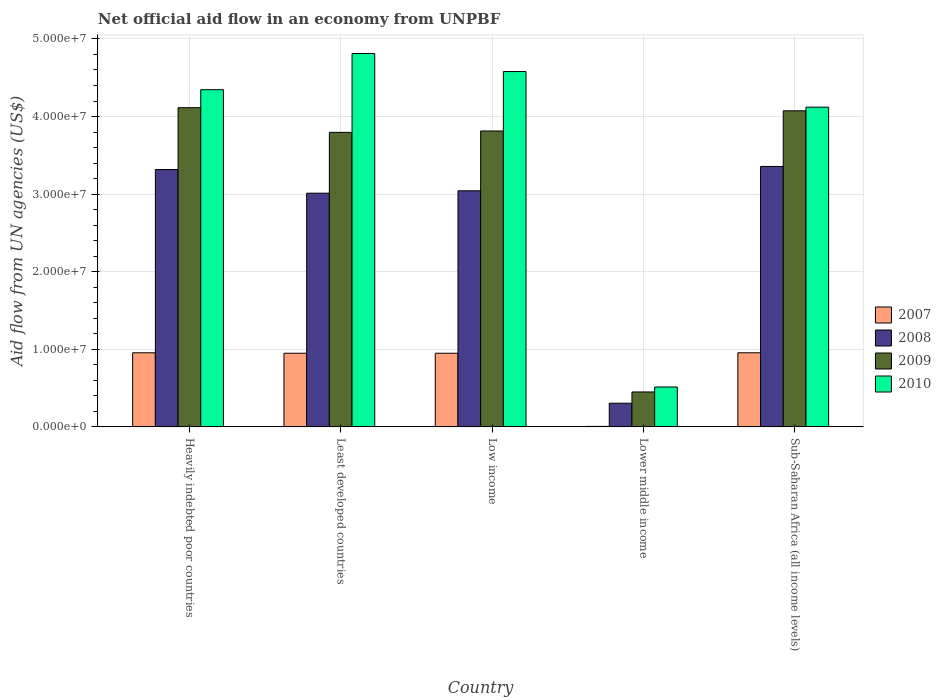How many groups of bars are there?
Ensure brevity in your answer.  5. Are the number of bars per tick equal to the number of legend labels?
Your answer should be very brief. Yes. Are the number of bars on each tick of the X-axis equal?
Keep it short and to the point. Yes. What is the label of the 2nd group of bars from the left?
Make the answer very short. Least developed countries. What is the net official aid flow in 2008 in Low income?
Provide a succinct answer. 3.04e+07. Across all countries, what is the maximum net official aid flow in 2008?
Keep it short and to the point. 3.36e+07. Across all countries, what is the minimum net official aid flow in 2009?
Offer a very short reply. 4.50e+06. In which country was the net official aid flow in 2010 maximum?
Your answer should be compact. Least developed countries. In which country was the net official aid flow in 2007 minimum?
Provide a succinct answer. Lower middle income. What is the total net official aid flow in 2007 in the graph?
Offer a very short reply. 3.81e+07. What is the difference between the net official aid flow in 2007 in Least developed countries and that in Lower middle income?
Give a very brief answer. 9.43e+06. What is the difference between the net official aid flow in 2008 in Lower middle income and the net official aid flow in 2010 in Heavily indebted poor countries?
Give a very brief answer. -4.04e+07. What is the average net official aid flow in 2007 per country?
Provide a short and direct response. 7.63e+06. What is the difference between the net official aid flow of/in 2008 and net official aid flow of/in 2007 in Lower middle income?
Your answer should be very brief. 2.99e+06. What is the ratio of the net official aid flow in 2007 in Least developed countries to that in Lower middle income?
Your answer should be very brief. 158.17. Is the net official aid flow in 2010 in Least developed countries less than that in Low income?
Offer a terse response. No. Is the difference between the net official aid flow in 2008 in Lower middle income and Sub-Saharan Africa (all income levels) greater than the difference between the net official aid flow in 2007 in Lower middle income and Sub-Saharan Africa (all income levels)?
Give a very brief answer. No. What is the difference between the highest and the lowest net official aid flow in 2008?
Make the answer very short. 3.05e+07. In how many countries, is the net official aid flow in 2008 greater than the average net official aid flow in 2008 taken over all countries?
Ensure brevity in your answer.  4. Is the sum of the net official aid flow in 2009 in Least developed countries and Low income greater than the maximum net official aid flow in 2007 across all countries?
Your response must be concise. Yes. Is it the case that in every country, the sum of the net official aid flow in 2008 and net official aid flow in 2009 is greater than the sum of net official aid flow in 2007 and net official aid flow in 2010?
Keep it short and to the point. No. How many bars are there?
Ensure brevity in your answer.  20. Are all the bars in the graph horizontal?
Your response must be concise. No. How many countries are there in the graph?
Ensure brevity in your answer.  5. Where does the legend appear in the graph?
Keep it short and to the point. Center right. How many legend labels are there?
Provide a succinct answer. 4. How are the legend labels stacked?
Provide a short and direct response. Vertical. What is the title of the graph?
Your answer should be compact. Net official aid flow in an economy from UNPBF. What is the label or title of the X-axis?
Offer a very short reply. Country. What is the label or title of the Y-axis?
Make the answer very short. Aid flow from UN agencies (US$). What is the Aid flow from UN agencies (US$) in 2007 in Heavily indebted poor countries?
Ensure brevity in your answer.  9.55e+06. What is the Aid flow from UN agencies (US$) of 2008 in Heavily indebted poor countries?
Offer a very short reply. 3.32e+07. What is the Aid flow from UN agencies (US$) in 2009 in Heavily indebted poor countries?
Offer a very short reply. 4.11e+07. What is the Aid flow from UN agencies (US$) in 2010 in Heavily indebted poor countries?
Your answer should be very brief. 4.35e+07. What is the Aid flow from UN agencies (US$) in 2007 in Least developed countries?
Keep it short and to the point. 9.49e+06. What is the Aid flow from UN agencies (US$) in 2008 in Least developed countries?
Your response must be concise. 3.01e+07. What is the Aid flow from UN agencies (US$) of 2009 in Least developed countries?
Provide a short and direct response. 3.80e+07. What is the Aid flow from UN agencies (US$) of 2010 in Least developed countries?
Keep it short and to the point. 4.81e+07. What is the Aid flow from UN agencies (US$) in 2007 in Low income?
Provide a short and direct response. 9.49e+06. What is the Aid flow from UN agencies (US$) of 2008 in Low income?
Offer a very short reply. 3.04e+07. What is the Aid flow from UN agencies (US$) in 2009 in Low income?
Offer a terse response. 3.81e+07. What is the Aid flow from UN agencies (US$) in 2010 in Low income?
Ensure brevity in your answer.  4.58e+07. What is the Aid flow from UN agencies (US$) in 2007 in Lower middle income?
Offer a very short reply. 6.00e+04. What is the Aid flow from UN agencies (US$) of 2008 in Lower middle income?
Your answer should be compact. 3.05e+06. What is the Aid flow from UN agencies (US$) in 2009 in Lower middle income?
Your response must be concise. 4.50e+06. What is the Aid flow from UN agencies (US$) of 2010 in Lower middle income?
Provide a short and direct response. 5.14e+06. What is the Aid flow from UN agencies (US$) of 2007 in Sub-Saharan Africa (all income levels)?
Offer a terse response. 9.55e+06. What is the Aid flow from UN agencies (US$) of 2008 in Sub-Saharan Africa (all income levels)?
Provide a succinct answer. 3.36e+07. What is the Aid flow from UN agencies (US$) of 2009 in Sub-Saharan Africa (all income levels)?
Make the answer very short. 4.07e+07. What is the Aid flow from UN agencies (US$) of 2010 in Sub-Saharan Africa (all income levels)?
Your answer should be compact. 4.12e+07. Across all countries, what is the maximum Aid flow from UN agencies (US$) of 2007?
Your answer should be very brief. 9.55e+06. Across all countries, what is the maximum Aid flow from UN agencies (US$) in 2008?
Offer a terse response. 3.36e+07. Across all countries, what is the maximum Aid flow from UN agencies (US$) in 2009?
Make the answer very short. 4.11e+07. Across all countries, what is the maximum Aid flow from UN agencies (US$) in 2010?
Offer a terse response. 4.81e+07. Across all countries, what is the minimum Aid flow from UN agencies (US$) of 2008?
Your answer should be very brief. 3.05e+06. Across all countries, what is the minimum Aid flow from UN agencies (US$) in 2009?
Provide a short and direct response. 4.50e+06. Across all countries, what is the minimum Aid flow from UN agencies (US$) of 2010?
Provide a succinct answer. 5.14e+06. What is the total Aid flow from UN agencies (US$) of 2007 in the graph?
Your answer should be compact. 3.81e+07. What is the total Aid flow from UN agencies (US$) of 2008 in the graph?
Provide a short and direct response. 1.30e+08. What is the total Aid flow from UN agencies (US$) of 2009 in the graph?
Your answer should be very brief. 1.62e+08. What is the total Aid flow from UN agencies (US$) of 2010 in the graph?
Ensure brevity in your answer.  1.84e+08. What is the difference between the Aid flow from UN agencies (US$) in 2007 in Heavily indebted poor countries and that in Least developed countries?
Offer a very short reply. 6.00e+04. What is the difference between the Aid flow from UN agencies (US$) in 2008 in Heavily indebted poor countries and that in Least developed countries?
Ensure brevity in your answer.  3.05e+06. What is the difference between the Aid flow from UN agencies (US$) in 2009 in Heavily indebted poor countries and that in Least developed countries?
Provide a short and direct response. 3.18e+06. What is the difference between the Aid flow from UN agencies (US$) of 2010 in Heavily indebted poor countries and that in Least developed countries?
Offer a terse response. -4.66e+06. What is the difference between the Aid flow from UN agencies (US$) of 2007 in Heavily indebted poor countries and that in Low income?
Keep it short and to the point. 6.00e+04. What is the difference between the Aid flow from UN agencies (US$) in 2008 in Heavily indebted poor countries and that in Low income?
Your answer should be compact. 2.74e+06. What is the difference between the Aid flow from UN agencies (US$) of 2010 in Heavily indebted poor countries and that in Low income?
Make the answer very short. -2.34e+06. What is the difference between the Aid flow from UN agencies (US$) of 2007 in Heavily indebted poor countries and that in Lower middle income?
Provide a short and direct response. 9.49e+06. What is the difference between the Aid flow from UN agencies (US$) in 2008 in Heavily indebted poor countries and that in Lower middle income?
Provide a succinct answer. 3.01e+07. What is the difference between the Aid flow from UN agencies (US$) in 2009 in Heavily indebted poor countries and that in Lower middle income?
Ensure brevity in your answer.  3.66e+07. What is the difference between the Aid flow from UN agencies (US$) in 2010 in Heavily indebted poor countries and that in Lower middle income?
Offer a very short reply. 3.83e+07. What is the difference between the Aid flow from UN agencies (US$) in 2007 in Heavily indebted poor countries and that in Sub-Saharan Africa (all income levels)?
Offer a very short reply. 0. What is the difference between the Aid flow from UN agencies (US$) in 2008 in Heavily indebted poor countries and that in Sub-Saharan Africa (all income levels)?
Ensure brevity in your answer.  -4.00e+05. What is the difference between the Aid flow from UN agencies (US$) of 2009 in Heavily indebted poor countries and that in Sub-Saharan Africa (all income levels)?
Provide a succinct answer. 4.00e+05. What is the difference between the Aid flow from UN agencies (US$) of 2010 in Heavily indebted poor countries and that in Sub-Saharan Africa (all income levels)?
Provide a short and direct response. 2.25e+06. What is the difference between the Aid flow from UN agencies (US$) of 2008 in Least developed countries and that in Low income?
Give a very brief answer. -3.10e+05. What is the difference between the Aid flow from UN agencies (US$) in 2010 in Least developed countries and that in Low income?
Provide a succinct answer. 2.32e+06. What is the difference between the Aid flow from UN agencies (US$) in 2007 in Least developed countries and that in Lower middle income?
Your answer should be compact. 9.43e+06. What is the difference between the Aid flow from UN agencies (US$) in 2008 in Least developed countries and that in Lower middle income?
Provide a succinct answer. 2.71e+07. What is the difference between the Aid flow from UN agencies (US$) in 2009 in Least developed countries and that in Lower middle income?
Ensure brevity in your answer.  3.35e+07. What is the difference between the Aid flow from UN agencies (US$) of 2010 in Least developed countries and that in Lower middle income?
Your response must be concise. 4.30e+07. What is the difference between the Aid flow from UN agencies (US$) in 2008 in Least developed countries and that in Sub-Saharan Africa (all income levels)?
Ensure brevity in your answer.  -3.45e+06. What is the difference between the Aid flow from UN agencies (US$) of 2009 in Least developed countries and that in Sub-Saharan Africa (all income levels)?
Your answer should be very brief. -2.78e+06. What is the difference between the Aid flow from UN agencies (US$) in 2010 in Least developed countries and that in Sub-Saharan Africa (all income levels)?
Provide a succinct answer. 6.91e+06. What is the difference between the Aid flow from UN agencies (US$) in 2007 in Low income and that in Lower middle income?
Make the answer very short. 9.43e+06. What is the difference between the Aid flow from UN agencies (US$) in 2008 in Low income and that in Lower middle income?
Keep it short and to the point. 2.74e+07. What is the difference between the Aid flow from UN agencies (US$) in 2009 in Low income and that in Lower middle income?
Keep it short and to the point. 3.36e+07. What is the difference between the Aid flow from UN agencies (US$) of 2010 in Low income and that in Lower middle income?
Provide a succinct answer. 4.07e+07. What is the difference between the Aid flow from UN agencies (US$) in 2008 in Low income and that in Sub-Saharan Africa (all income levels)?
Make the answer very short. -3.14e+06. What is the difference between the Aid flow from UN agencies (US$) of 2009 in Low income and that in Sub-Saharan Africa (all income levels)?
Make the answer very short. -2.60e+06. What is the difference between the Aid flow from UN agencies (US$) in 2010 in Low income and that in Sub-Saharan Africa (all income levels)?
Make the answer very short. 4.59e+06. What is the difference between the Aid flow from UN agencies (US$) in 2007 in Lower middle income and that in Sub-Saharan Africa (all income levels)?
Keep it short and to the point. -9.49e+06. What is the difference between the Aid flow from UN agencies (US$) in 2008 in Lower middle income and that in Sub-Saharan Africa (all income levels)?
Your response must be concise. -3.05e+07. What is the difference between the Aid flow from UN agencies (US$) in 2009 in Lower middle income and that in Sub-Saharan Africa (all income levels)?
Give a very brief answer. -3.62e+07. What is the difference between the Aid flow from UN agencies (US$) of 2010 in Lower middle income and that in Sub-Saharan Africa (all income levels)?
Give a very brief answer. -3.61e+07. What is the difference between the Aid flow from UN agencies (US$) of 2007 in Heavily indebted poor countries and the Aid flow from UN agencies (US$) of 2008 in Least developed countries?
Give a very brief answer. -2.06e+07. What is the difference between the Aid flow from UN agencies (US$) of 2007 in Heavily indebted poor countries and the Aid flow from UN agencies (US$) of 2009 in Least developed countries?
Ensure brevity in your answer.  -2.84e+07. What is the difference between the Aid flow from UN agencies (US$) of 2007 in Heavily indebted poor countries and the Aid flow from UN agencies (US$) of 2010 in Least developed countries?
Make the answer very short. -3.86e+07. What is the difference between the Aid flow from UN agencies (US$) of 2008 in Heavily indebted poor countries and the Aid flow from UN agencies (US$) of 2009 in Least developed countries?
Your response must be concise. -4.79e+06. What is the difference between the Aid flow from UN agencies (US$) in 2008 in Heavily indebted poor countries and the Aid flow from UN agencies (US$) in 2010 in Least developed countries?
Your answer should be compact. -1.50e+07. What is the difference between the Aid flow from UN agencies (US$) in 2009 in Heavily indebted poor countries and the Aid flow from UN agencies (US$) in 2010 in Least developed countries?
Offer a terse response. -6.98e+06. What is the difference between the Aid flow from UN agencies (US$) of 2007 in Heavily indebted poor countries and the Aid flow from UN agencies (US$) of 2008 in Low income?
Offer a very short reply. -2.09e+07. What is the difference between the Aid flow from UN agencies (US$) of 2007 in Heavily indebted poor countries and the Aid flow from UN agencies (US$) of 2009 in Low income?
Offer a very short reply. -2.86e+07. What is the difference between the Aid flow from UN agencies (US$) of 2007 in Heavily indebted poor countries and the Aid flow from UN agencies (US$) of 2010 in Low income?
Provide a short and direct response. -3.62e+07. What is the difference between the Aid flow from UN agencies (US$) in 2008 in Heavily indebted poor countries and the Aid flow from UN agencies (US$) in 2009 in Low income?
Your answer should be compact. -4.97e+06. What is the difference between the Aid flow from UN agencies (US$) of 2008 in Heavily indebted poor countries and the Aid flow from UN agencies (US$) of 2010 in Low income?
Offer a terse response. -1.26e+07. What is the difference between the Aid flow from UN agencies (US$) of 2009 in Heavily indebted poor countries and the Aid flow from UN agencies (US$) of 2010 in Low income?
Provide a short and direct response. -4.66e+06. What is the difference between the Aid flow from UN agencies (US$) in 2007 in Heavily indebted poor countries and the Aid flow from UN agencies (US$) in 2008 in Lower middle income?
Offer a terse response. 6.50e+06. What is the difference between the Aid flow from UN agencies (US$) in 2007 in Heavily indebted poor countries and the Aid flow from UN agencies (US$) in 2009 in Lower middle income?
Offer a terse response. 5.05e+06. What is the difference between the Aid flow from UN agencies (US$) of 2007 in Heavily indebted poor countries and the Aid flow from UN agencies (US$) of 2010 in Lower middle income?
Make the answer very short. 4.41e+06. What is the difference between the Aid flow from UN agencies (US$) in 2008 in Heavily indebted poor countries and the Aid flow from UN agencies (US$) in 2009 in Lower middle income?
Provide a succinct answer. 2.87e+07. What is the difference between the Aid flow from UN agencies (US$) in 2008 in Heavily indebted poor countries and the Aid flow from UN agencies (US$) in 2010 in Lower middle income?
Ensure brevity in your answer.  2.80e+07. What is the difference between the Aid flow from UN agencies (US$) in 2009 in Heavily indebted poor countries and the Aid flow from UN agencies (US$) in 2010 in Lower middle income?
Give a very brief answer. 3.60e+07. What is the difference between the Aid flow from UN agencies (US$) of 2007 in Heavily indebted poor countries and the Aid flow from UN agencies (US$) of 2008 in Sub-Saharan Africa (all income levels)?
Give a very brief answer. -2.40e+07. What is the difference between the Aid flow from UN agencies (US$) in 2007 in Heavily indebted poor countries and the Aid flow from UN agencies (US$) in 2009 in Sub-Saharan Africa (all income levels)?
Your response must be concise. -3.12e+07. What is the difference between the Aid flow from UN agencies (US$) of 2007 in Heavily indebted poor countries and the Aid flow from UN agencies (US$) of 2010 in Sub-Saharan Africa (all income levels)?
Your answer should be compact. -3.17e+07. What is the difference between the Aid flow from UN agencies (US$) of 2008 in Heavily indebted poor countries and the Aid flow from UN agencies (US$) of 2009 in Sub-Saharan Africa (all income levels)?
Provide a succinct answer. -7.57e+06. What is the difference between the Aid flow from UN agencies (US$) of 2008 in Heavily indebted poor countries and the Aid flow from UN agencies (US$) of 2010 in Sub-Saharan Africa (all income levels)?
Your answer should be very brief. -8.04e+06. What is the difference between the Aid flow from UN agencies (US$) of 2007 in Least developed countries and the Aid flow from UN agencies (US$) of 2008 in Low income?
Provide a short and direct response. -2.09e+07. What is the difference between the Aid flow from UN agencies (US$) in 2007 in Least developed countries and the Aid flow from UN agencies (US$) in 2009 in Low income?
Offer a terse response. -2.86e+07. What is the difference between the Aid flow from UN agencies (US$) in 2007 in Least developed countries and the Aid flow from UN agencies (US$) in 2010 in Low income?
Provide a succinct answer. -3.63e+07. What is the difference between the Aid flow from UN agencies (US$) in 2008 in Least developed countries and the Aid flow from UN agencies (US$) in 2009 in Low income?
Keep it short and to the point. -8.02e+06. What is the difference between the Aid flow from UN agencies (US$) of 2008 in Least developed countries and the Aid flow from UN agencies (US$) of 2010 in Low income?
Offer a very short reply. -1.57e+07. What is the difference between the Aid flow from UN agencies (US$) of 2009 in Least developed countries and the Aid flow from UN agencies (US$) of 2010 in Low income?
Make the answer very short. -7.84e+06. What is the difference between the Aid flow from UN agencies (US$) in 2007 in Least developed countries and the Aid flow from UN agencies (US$) in 2008 in Lower middle income?
Your answer should be compact. 6.44e+06. What is the difference between the Aid flow from UN agencies (US$) in 2007 in Least developed countries and the Aid flow from UN agencies (US$) in 2009 in Lower middle income?
Give a very brief answer. 4.99e+06. What is the difference between the Aid flow from UN agencies (US$) in 2007 in Least developed countries and the Aid flow from UN agencies (US$) in 2010 in Lower middle income?
Offer a terse response. 4.35e+06. What is the difference between the Aid flow from UN agencies (US$) in 2008 in Least developed countries and the Aid flow from UN agencies (US$) in 2009 in Lower middle income?
Your answer should be compact. 2.56e+07. What is the difference between the Aid flow from UN agencies (US$) in 2008 in Least developed countries and the Aid flow from UN agencies (US$) in 2010 in Lower middle income?
Offer a terse response. 2.50e+07. What is the difference between the Aid flow from UN agencies (US$) in 2009 in Least developed countries and the Aid flow from UN agencies (US$) in 2010 in Lower middle income?
Ensure brevity in your answer.  3.28e+07. What is the difference between the Aid flow from UN agencies (US$) in 2007 in Least developed countries and the Aid flow from UN agencies (US$) in 2008 in Sub-Saharan Africa (all income levels)?
Provide a succinct answer. -2.41e+07. What is the difference between the Aid flow from UN agencies (US$) in 2007 in Least developed countries and the Aid flow from UN agencies (US$) in 2009 in Sub-Saharan Africa (all income levels)?
Keep it short and to the point. -3.12e+07. What is the difference between the Aid flow from UN agencies (US$) in 2007 in Least developed countries and the Aid flow from UN agencies (US$) in 2010 in Sub-Saharan Africa (all income levels)?
Give a very brief answer. -3.17e+07. What is the difference between the Aid flow from UN agencies (US$) in 2008 in Least developed countries and the Aid flow from UN agencies (US$) in 2009 in Sub-Saharan Africa (all income levels)?
Keep it short and to the point. -1.06e+07. What is the difference between the Aid flow from UN agencies (US$) in 2008 in Least developed countries and the Aid flow from UN agencies (US$) in 2010 in Sub-Saharan Africa (all income levels)?
Provide a succinct answer. -1.11e+07. What is the difference between the Aid flow from UN agencies (US$) of 2009 in Least developed countries and the Aid flow from UN agencies (US$) of 2010 in Sub-Saharan Africa (all income levels)?
Keep it short and to the point. -3.25e+06. What is the difference between the Aid flow from UN agencies (US$) in 2007 in Low income and the Aid flow from UN agencies (US$) in 2008 in Lower middle income?
Give a very brief answer. 6.44e+06. What is the difference between the Aid flow from UN agencies (US$) of 2007 in Low income and the Aid flow from UN agencies (US$) of 2009 in Lower middle income?
Your answer should be very brief. 4.99e+06. What is the difference between the Aid flow from UN agencies (US$) of 2007 in Low income and the Aid flow from UN agencies (US$) of 2010 in Lower middle income?
Offer a terse response. 4.35e+06. What is the difference between the Aid flow from UN agencies (US$) in 2008 in Low income and the Aid flow from UN agencies (US$) in 2009 in Lower middle income?
Give a very brief answer. 2.59e+07. What is the difference between the Aid flow from UN agencies (US$) in 2008 in Low income and the Aid flow from UN agencies (US$) in 2010 in Lower middle income?
Keep it short and to the point. 2.53e+07. What is the difference between the Aid flow from UN agencies (US$) of 2009 in Low income and the Aid flow from UN agencies (US$) of 2010 in Lower middle income?
Make the answer very short. 3.30e+07. What is the difference between the Aid flow from UN agencies (US$) in 2007 in Low income and the Aid flow from UN agencies (US$) in 2008 in Sub-Saharan Africa (all income levels)?
Your answer should be very brief. -2.41e+07. What is the difference between the Aid flow from UN agencies (US$) of 2007 in Low income and the Aid flow from UN agencies (US$) of 2009 in Sub-Saharan Africa (all income levels)?
Your response must be concise. -3.12e+07. What is the difference between the Aid flow from UN agencies (US$) in 2007 in Low income and the Aid flow from UN agencies (US$) in 2010 in Sub-Saharan Africa (all income levels)?
Your answer should be compact. -3.17e+07. What is the difference between the Aid flow from UN agencies (US$) of 2008 in Low income and the Aid flow from UN agencies (US$) of 2009 in Sub-Saharan Africa (all income levels)?
Your response must be concise. -1.03e+07. What is the difference between the Aid flow from UN agencies (US$) of 2008 in Low income and the Aid flow from UN agencies (US$) of 2010 in Sub-Saharan Africa (all income levels)?
Offer a very short reply. -1.08e+07. What is the difference between the Aid flow from UN agencies (US$) of 2009 in Low income and the Aid flow from UN agencies (US$) of 2010 in Sub-Saharan Africa (all income levels)?
Your response must be concise. -3.07e+06. What is the difference between the Aid flow from UN agencies (US$) of 2007 in Lower middle income and the Aid flow from UN agencies (US$) of 2008 in Sub-Saharan Africa (all income levels)?
Provide a short and direct response. -3.35e+07. What is the difference between the Aid flow from UN agencies (US$) of 2007 in Lower middle income and the Aid flow from UN agencies (US$) of 2009 in Sub-Saharan Africa (all income levels)?
Your answer should be compact. -4.07e+07. What is the difference between the Aid flow from UN agencies (US$) of 2007 in Lower middle income and the Aid flow from UN agencies (US$) of 2010 in Sub-Saharan Africa (all income levels)?
Your answer should be very brief. -4.12e+07. What is the difference between the Aid flow from UN agencies (US$) of 2008 in Lower middle income and the Aid flow from UN agencies (US$) of 2009 in Sub-Saharan Africa (all income levels)?
Keep it short and to the point. -3.77e+07. What is the difference between the Aid flow from UN agencies (US$) of 2008 in Lower middle income and the Aid flow from UN agencies (US$) of 2010 in Sub-Saharan Africa (all income levels)?
Offer a very short reply. -3.82e+07. What is the difference between the Aid flow from UN agencies (US$) in 2009 in Lower middle income and the Aid flow from UN agencies (US$) in 2010 in Sub-Saharan Africa (all income levels)?
Ensure brevity in your answer.  -3.67e+07. What is the average Aid flow from UN agencies (US$) of 2007 per country?
Give a very brief answer. 7.63e+06. What is the average Aid flow from UN agencies (US$) of 2008 per country?
Provide a short and direct response. 2.61e+07. What is the average Aid flow from UN agencies (US$) in 2009 per country?
Your response must be concise. 3.25e+07. What is the average Aid flow from UN agencies (US$) of 2010 per country?
Offer a terse response. 3.67e+07. What is the difference between the Aid flow from UN agencies (US$) in 2007 and Aid flow from UN agencies (US$) in 2008 in Heavily indebted poor countries?
Keep it short and to the point. -2.36e+07. What is the difference between the Aid flow from UN agencies (US$) of 2007 and Aid flow from UN agencies (US$) of 2009 in Heavily indebted poor countries?
Keep it short and to the point. -3.16e+07. What is the difference between the Aid flow from UN agencies (US$) in 2007 and Aid flow from UN agencies (US$) in 2010 in Heavily indebted poor countries?
Ensure brevity in your answer.  -3.39e+07. What is the difference between the Aid flow from UN agencies (US$) in 2008 and Aid flow from UN agencies (US$) in 2009 in Heavily indebted poor countries?
Make the answer very short. -7.97e+06. What is the difference between the Aid flow from UN agencies (US$) in 2008 and Aid flow from UN agencies (US$) in 2010 in Heavily indebted poor countries?
Your answer should be compact. -1.03e+07. What is the difference between the Aid flow from UN agencies (US$) in 2009 and Aid flow from UN agencies (US$) in 2010 in Heavily indebted poor countries?
Offer a very short reply. -2.32e+06. What is the difference between the Aid flow from UN agencies (US$) in 2007 and Aid flow from UN agencies (US$) in 2008 in Least developed countries?
Provide a succinct answer. -2.06e+07. What is the difference between the Aid flow from UN agencies (US$) in 2007 and Aid flow from UN agencies (US$) in 2009 in Least developed countries?
Your response must be concise. -2.85e+07. What is the difference between the Aid flow from UN agencies (US$) in 2007 and Aid flow from UN agencies (US$) in 2010 in Least developed countries?
Keep it short and to the point. -3.86e+07. What is the difference between the Aid flow from UN agencies (US$) in 2008 and Aid flow from UN agencies (US$) in 2009 in Least developed countries?
Provide a succinct answer. -7.84e+06. What is the difference between the Aid flow from UN agencies (US$) of 2008 and Aid flow from UN agencies (US$) of 2010 in Least developed countries?
Provide a succinct answer. -1.80e+07. What is the difference between the Aid flow from UN agencies (US$) in 2009 and Aid flow from UN agencies (US$) in 2010 in Least developed countries?
Offer a terse response. -1.02e+07. What is the difference between the Aid flow from UN agencies (US$) in 2007 and Aid flow from UN agencies (US$) in 2008 in Low income?
Give a very brief answer. -2.09e+07. What is the difference between the Aid flow from UN agencies (US$) of 2007 and Aid flow from UN agencies (US$) of 2009 in Low income?
Keep it short and to the point. -2.86e+07. What is the difference between the Aid flow from UN agencies (US$) in 2007 and Aid flow from UN agencies (US$) in 2010 in Low income?
Offer a terse response. -3.63e+07. What is the difference between the Aid flow from UN agencies (US$) of 2008 and Aid flow from UN agencies (US$) of 2009 in Low income?
Provide a short and direct response. -7.71e+06. What is the difference between the Aid flow from UN agencies (US$) of 2008 and Aid flow from UN agencies (US$) of 2010 in Low income?
Ensure brevity in your answer.  -1.54e+07. What is the difference between the Aid flow from UN agencies (US$) of 2009 and Aid flow from UN agencies (US$) of 2010 in Low income?
Your answer should be very brief. -7.66e+06. What is the difference between the Aid flow from UN agencies (US$) of 2007 and Aid flow from UN agencies (US$) of 2008 in Lower middle income?
Provide a short and direct response. -2.99e+06. What is the difference between the Aid flow from UN agencies (US$) in 2007 and Aid flow from UN agencies (US$) in 2009 in Lower middle income?
Provide a short and direct response. -4.44e+06. What is the difference between the Aid flow from UN agencies (US$) in 2007 and Aid flow from UN agencies (US$) in 2010 in Lower middle income?
Provide a short and direct response. -5.08e+06. What is the difference between the Aid flow from UN agencies (US$) of 2008 and Aid flow from UN agencies (US$) of 2009 in Lower middle income?
Your response must be concise. -1.45e+06. What is the difference between the Aid flow from UN agencies (US$) in 2008 and Aid flow from UN agencies (US$) in 2010 in Lower middle income?
Give a very brief answer. -2.09e+06. What is the difference between the Aid flow from UN agencies (US$) in 2009 and Aid flow from UN agencies (US$) in 2010 in Lower middle income?
Offer a terse response. -6.40e+05. What is the difference between the Aid flow from UN agencies (US$) of 2007 and Aid flow from UN agencies (US$) of 2008 in Sub-Saharan Africa (all income levels)?
Make the answer very short. -2.40e+07. What is the difference between the Aid flow from UN agencies (US$) of 2007 and Aid flow from UN agencies (US$) of 2009 in Sub-Saharan Africa (all income levels)?
Offer a terse response. -3.12e+07. What is the difference between the Aid flow from UN agencies (US$) in 2007 and Aid flow from UN agencies (US$) in 2010 in Sub-Saharan Africa (all income levels)?
Provide a succinct answer. -3.17e+07. What is the difference between the Aid flow from UN agencies (US$) in 2008 and Aid flow from UN agencies (US$) in 2009 in Sub-Saharan Africa (all income levels)?
Make the answer very short. -7.17e+06. What is the difference between the Aid flow from UN agencies (US$) in 2008 and Aid flow from UN agencies (US$) in 2010 in Sub-Saharan Africa (all income levels)?
Provide a succinct answer. -7.64e+06. What is the difference between the Aid flow from UN agencies (US$) of 2009 and Aid flow from UN agencies (US$) of 2010 in Sub-Saharan Africa (all income levels)?
Your answer should be very brief. -4.70e+05. What is the ratio of the Aid flow from UN agencies (US$) in 2007 in Heavily indebted poor countries to that in Least developed countries?
Provide a short and direct response. 1.01. What is the ratio of the Aid flow from UN agencies (US$) of 2008 in Heavily indebted poor countries to that in Least developed countries?
Your answer should be very brief. 1.1. What is the ratio of the Aid flow from UN agencies (US$) of 2009 in Heavily indebted poor countries to that in Least developed countries?
Give a very brief answer. 1.08. What is the ratio of the Aid flow from UN agencies (US$) in 2010 in Heavily indebted poor countries to that in Least developed countries?
Offer a very short reply. 0.9. What is the ratio of the Aid flow from UN agencies (US$) in 2007 in Heavily indebted poor countries to that in Low income?
Provide a short and direct response. 1.01. What is the ratio of the Aid flow from UN agencies (US$) of 2008 in Heavily indebted poor countries to that in Low income?
Ensure brevity in your answer.  1.09. What is the ratio of the Aid flow from UN agencies (US$) in 2009 in Heavily indebted poor countries to that in Low income?
Ensure brevity in your answer.  1.08. What is the ratio of the Aid flow from UN agencies (US$) in 2010 in Heavily indebted poor countries to that in Low income?
Your answer should be compact. 0.95. What is the ratio of the Aid flow from UN agencies (US$) in 2007 in Heavily indebted poor countries to that in Lower middle income?
Offer a terse response. 159.17. What is the ratio of the Aid flow from UN agencies (US$) of 2008 in Heavily indebted poor countries to that in Lower middle income?
Keep it short and to the point. 10.88. What is the ratio of the Aid flow from UN agencies (US$) in 2009 in Heavily indebted poor countries to that in Lower middle income?
Provide a short and direct response. 9.14. What is the ratio of the Aid flow from UN agencies (US$) in 2010 in Heavily indebted poor countries to that in Lower middle income?
Your answer should be compact. 8.46. What is the ratio of the Aid flow from UN agencies (US$) of 2007 in Heavily indebted poor countries to that in Sub-Saharan Africa (all income levels)?
Make the answer very short. 1. What is the ratio of the Aid flow from UN agencies (US$) of 2009 in Heavily indebted poor countries to that in Sub-Saharan Africa (all income levels)?
Make the answer very short. 1.01. What is the ratio of the Aid flow from UN agencies (US$) of 2010 in Heavily indebted poor countries to that in Sub-Saharan Africa (all income levels)?
Provide a short and direct response. 1.05. What is the ratio of the Aid flow from UN agencies (US$) in 2007 in Least developed countries to that in Low income?
Keep it short and to the point. 1. What is the ratio of the Aid flow from UN agencies (US$) of 2008 in Least developed countries to that in Low income?
Offer a terse response. 0.99. What is the ratio of the Aid flow from UN agencies (US$) of 2009 in Least developed countries to that in Low income?
Give a very brief answer. 1. What is the ratio of the Aid flow from UN agencies (US$) of 2010 in Least developed countries to that in Low income?
Make the answer very short. 1.05. What is the ratio of the Aid flow from UN agencies (US$) of 2007 in Least developed countries to that in Lower middle income?
Make the answer very short. 158.17. What is the ratio of the Aid flow from UN agencies (US$) of 2008 in Least developed countries to that in Lower middle income?
Keep it short and to the point. 9.88. What is the ratio of the Aid flow from UN agencies (US$) in 2009 in Least developed countries to that in Lower middle income?
Provide a short and direct response. 8.44. What is the ratio of the Aid flow from UN agencies (US$) of 2010 in Least developed countries to that in Lower middle income?
Your answer should be compact. 9.36. What is the ratio of the Aid flow from UN agencies (US$) of 2007 in Least developed countries to that in Sub-Saharan Africa (all income levels)?
Your answer should be compact. 0.99. What is the ratio of the Aid flow from UN agencies (US$) in 2008 in Least developed countries to that in Sub-Saharan Africa (all income levels)?
Provide a short and direct response. 0.9. What is the ratio of the Aid flow from UN agencies (US$) of 2009 in Least developed countries to that in Sub-Saharan Africa (all income levels)?
Offer a terse response. 0.93. What is the ratio of the Aid flow from UN agencies (US$) of 2010 in Least developed countries to that in Sub-Saharan Africa (all income levels)?
Provide a short and direct response. 1.17. What is the ratio of the Aid flow from UN agencies (US$) of 2007 in Low income to that in Lower middle income?
Keep it short and to the point. 158.17. What is the ratio of the Aid flow from UN agencies (US$) of 2008 in Low income to that in Lower middle income?
Keep it short and to the point. 9.98. What is the ratio of the Aid flow from UN agencies (US$) in 2009 in Low income to that in Lower middle income?
Make the answer very short. 8.48. What is the ratio of the Aid flow from UN agencies (US$) in 2010 in Low income to that in Lower middle income?
Your answer should be compact. 8.91. What is the ratio of the Aid flow from UN agencies (US$) in 2007 in Low income to that in Sub-Saharan Africa (all income levels)?
Your answer should be compact. 0.99. What is the ratio of the Aid flow from UN agencies (US$) in 2008 in Low income to that in Sub-Saharan Africa (all income levels)?
Provide a short and direct response. 0.91. What is the ratio of the Aid flow from UN agencies (US$) of 2009 in Low income to that in Sub-Saharan Africa (all income levels)?
Your answer should be very brief. 0.94. What is the ratio of the Aid flow from UN agencies (US$) in 2010 in Low income to that in Sub-Saharan Africa (all income levels)?
Your answer should be compact. 1.11. What is the ratio of the Aid flow from UN agencies (US$) in 2007 in Lower middle income to that in Sub-Saharan Africa (all income levels)?
Provide a short and direct response. 0.01. What is the ratio of the Aid flow from UN agencies (US$) in 2008 in Lower middle income to that in Sub-Saharan Africa (all income levels)?
Offer a very short reply. 0.09. What is the ratio of the Aid flow from UN agencies (US$) of 2009 in Lower middle income to that in Sub-Saharan Africa (all income levels)?
Offer a very short reply. 0.11. What is the ratio of the Aid flow from UN agencies (US$) in 2010 in Lower middle income to that in Sub-Saharan Africa (all income levels)?
Ensure brevity in your answer.  0.12. What is the difference between the highest and the second highest Aid flow from UN agencies (US$) in 2007?
Keep it short and to the point. 0. What is the difference between the highest and the second highest Aid flow from UN agencies (US$) in 2010?
Offer a terse response. 2.32e+06. What is the difference between the highest and the lowest Aid flow from UN agencies (US$) of 2007?
Give a very brief answer. 9.49e+06. What is the difference between the highest and the lowest Aid flow from UN agencies (US$) in 2008?
Offer a very short reply. 3.05e+07. What is the difference between the highest and the lowest Aid flow from UN agencies (US$) of 2009?
Offer a very short reply. 3.66e+07. What is the difference between the highest and the lowest Aid flow from UN agencies (US$) in 2010?
Offer a very short reply. 4.30e+07. 